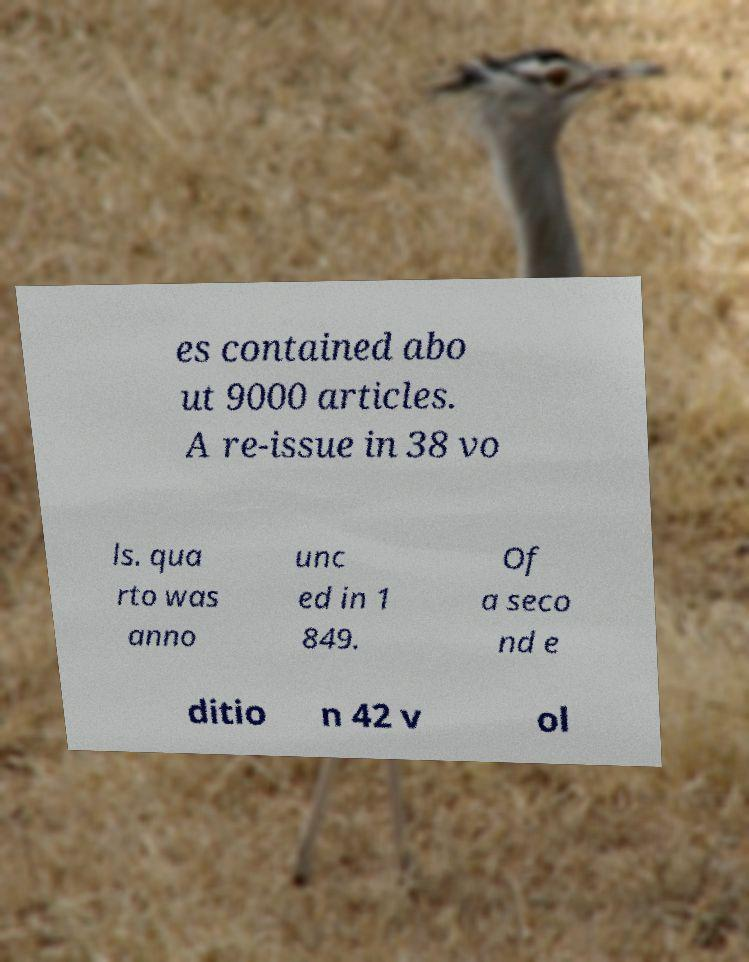There's text embedded in this image that I need extracted. Can you transcribe it verbatim? es contained abo ut 9000 articles. A re-issue in 38 vo ls. qua rto was anno unc ed in 1 849. Of a seco nd e ditio n 42 v ol 